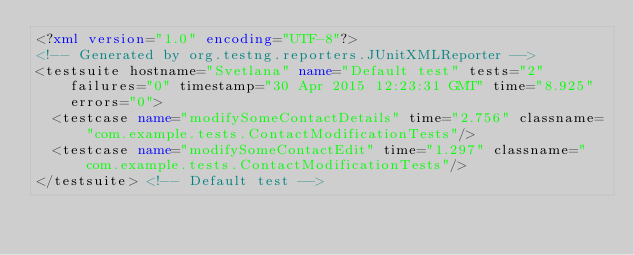<code> <loc_0><loc_0><loc_500><loc_500><_XML_><?xml version="1.0" encoding="UTF-8"?>
<!-- Generated by org.testng.reporters.JUnitXMLReporter -->
<testsuite hostname="Svetlana" name="Default test" tests="2" failures="0" timestamp="30 Apr 2015 12:23:31 GMT" time="8.925" errors="0">
  <testcase name="modifySomeContactDetails" time="2.756" classname="com.example.tests.ContactModificationTests"/>
  <testcase name="modifySomeContactEdit" time="1.297" classname="com.example.tests.ContactModificationTests"/>
</testsuite> <!-- Default test -->
</code> 